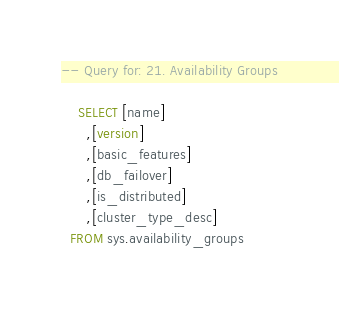Convert code to text. <code><loc_0><loc_0><loc_500><loc_500><_SQL_>-- Query for: 21. Availability Groups

    SELECT [name]
      ,[version]
      ,[basic_features]
      ,[db_failover]
      ,[is_distributed]
      ,[cluster_type_desc]
  FROM sys.availability_groups
    

</code> 